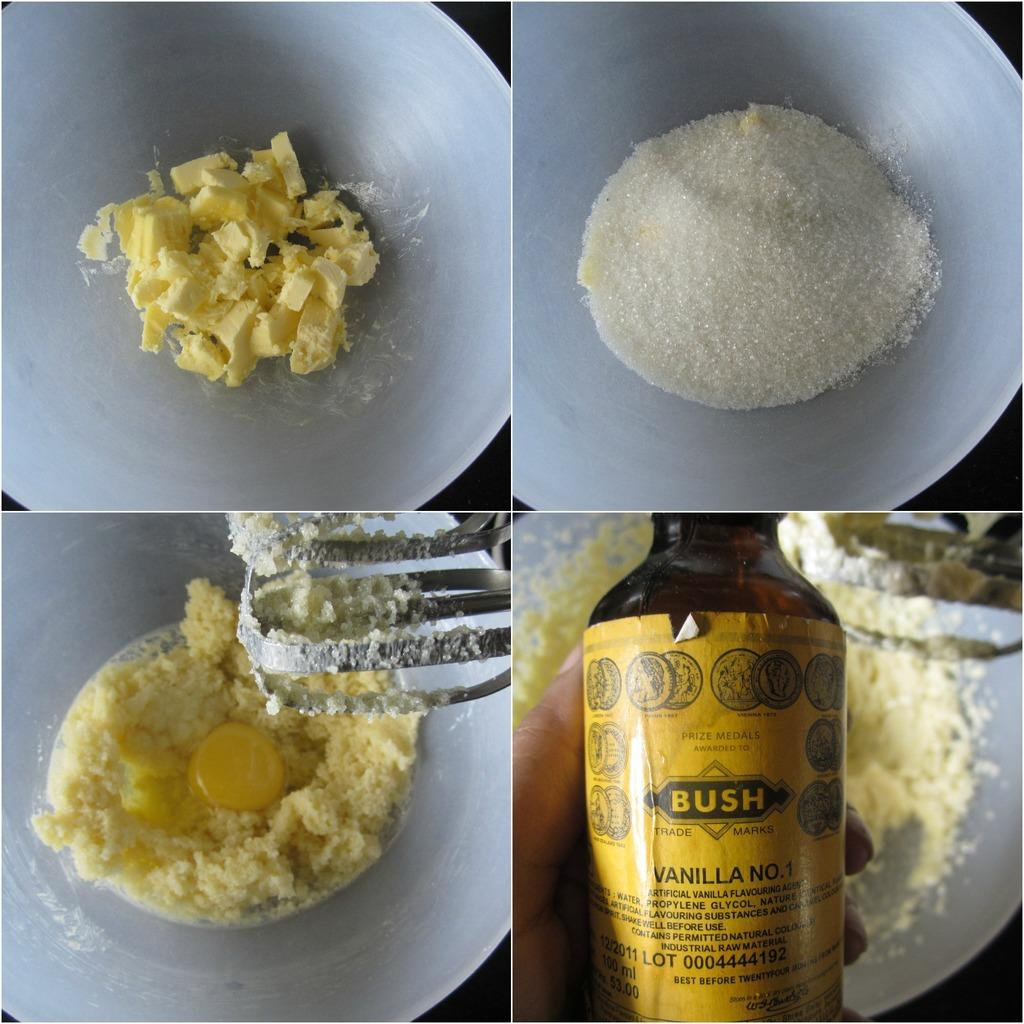<image>
Write a terse but informative summary of the picture. A recipe that shows how to make a treat using Bush vanilla essence 